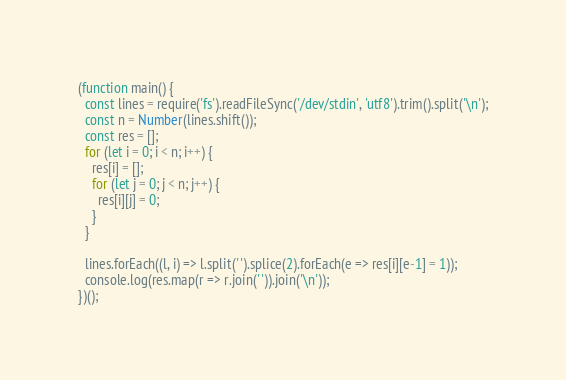<code> <loc_0><loc_0><loc_500><loc_500><_JavaScript_>(function main() {
  const lines = require('fs').readFileSync('/dev/stdin', 'utf8').trim().split('\n');
  const n = Number(lines.shift());
  const res = [];
  for (let i = 0; i < n; i++) {
    res[i] = [];
    for (let j = 0; j < n; j++) {
      res[i][j] = 0;
    }
  }

  lines.forEach((l, i) => l.split(' ').splice(2).forEach(e => res[i][e-1] = 1));
  console.log(res.map(r => r.join(' ')).join('\n'));
})();
</code> 